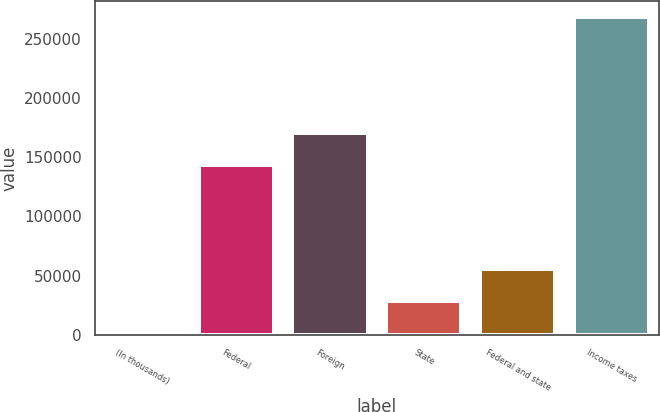<chart> <loc_0><loc_0><loc_500><loc_500><bar_chart><fcel>(In thousands)<fcel>Federal<fcel>Foreign<fcel>State<fcel>Federal and state<fcel>Income taxes<nl><fcel>2019<fcel>143872<fcel>170510<fcel>28657.1<fcel>55295.2<fcel>268400<nl></chart> 